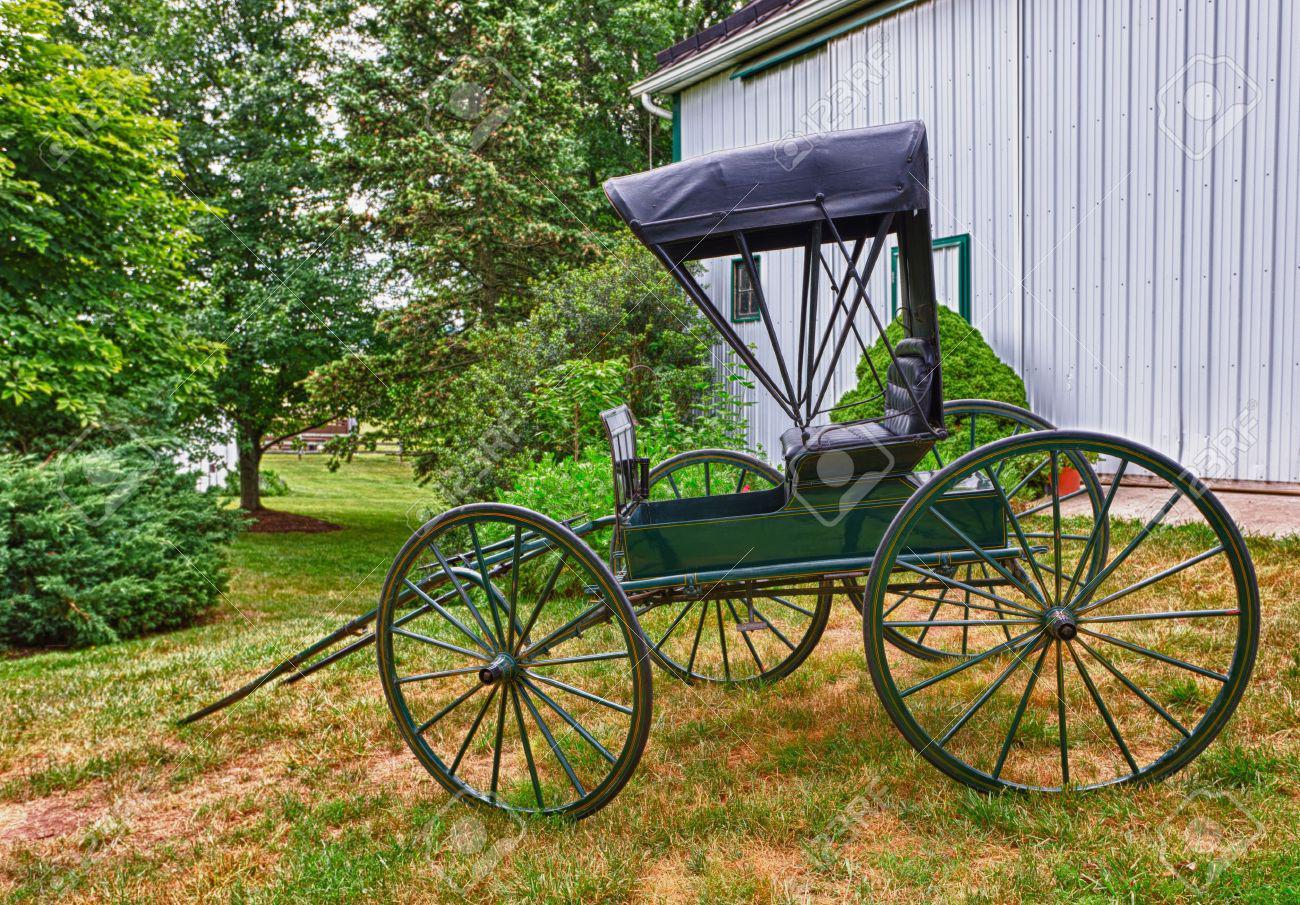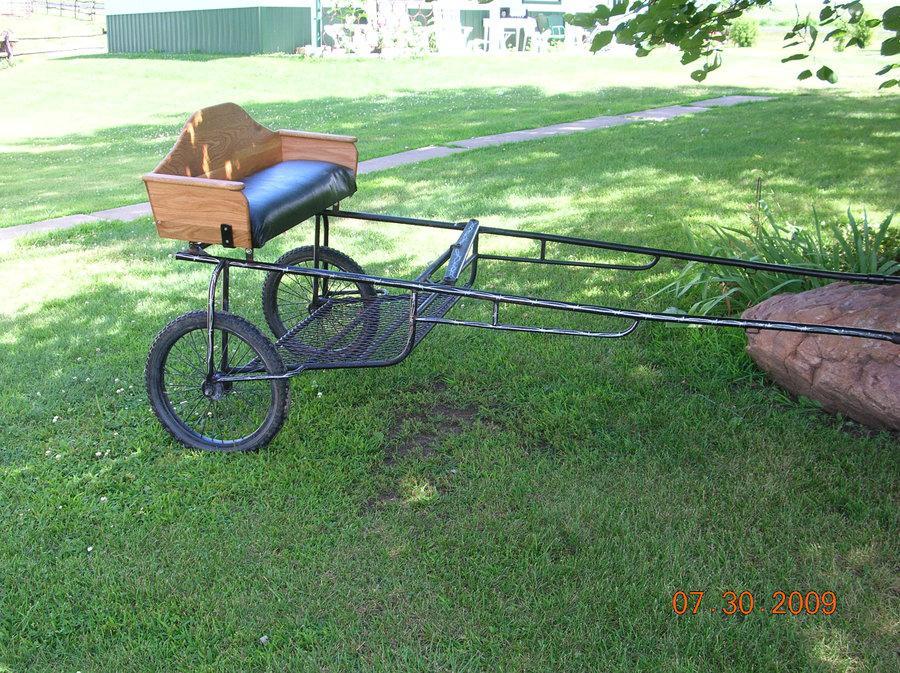The first image is the image on the left, the second image is the image on the right. Assess this claim about the two images: "A cart in one image is equipped with only two wheels on which are rubber tires.". Correct or not? Answer yes or no. Yes. 